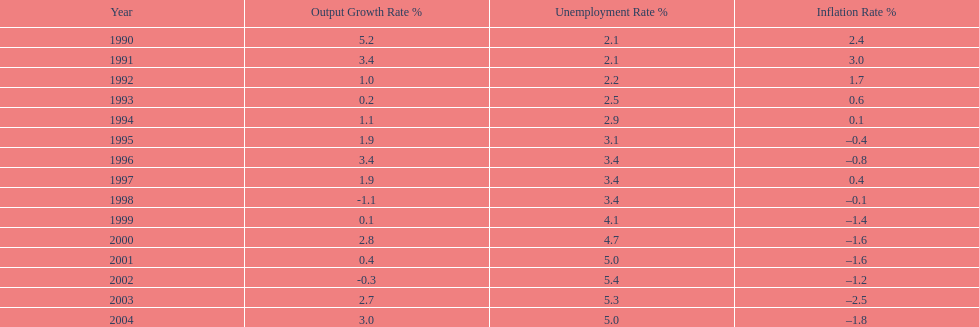Between 1990 and 2004, which years saw japan's unemployment rate hitting 5% or more? 4. 